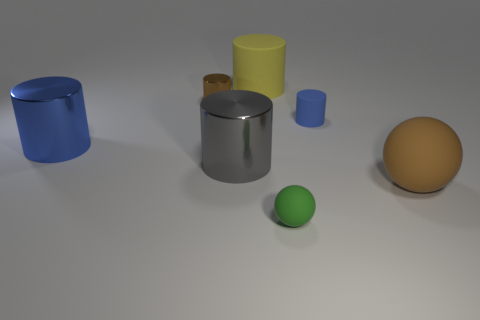How many matte objects are small cylinders or small spheres?
Ensure brevity in your answer.  2. What is the shape of the small blue object?
Provide a short and direct response. Cylinder. Are there any other things that have the same material as the big sphere?
Your response must be concise. Yes. Is the large ball made of the same material as the large gray object?
Provide a short and direct response. No. Are there any big rubber cylinders that are in front of the thing in front of the sphere that is right of the tiny blue matte cylinder?
Your response must be concise. No. What number of other things are the same shape as the big yellow rubber object?
Provide a short and direct response. 4. What is the shape of the object that is both right of the small brown object and behind the small matte cylinder?
Make the answer very short. Cylinder. What color is the small thing in front of the tiny cylinder that is on the right side of the large matte thing left of the big brown thing?
Ensure brevity in your answer.  Green. Are there more large gray cylinders on the left side of the large blue metal thing than blue metal objects that are behind the small shiny cylinder?
Provide a succinct answer. No. What number of other objects are there of the same size as the green matte thing?
Make the answer very short. 2. 